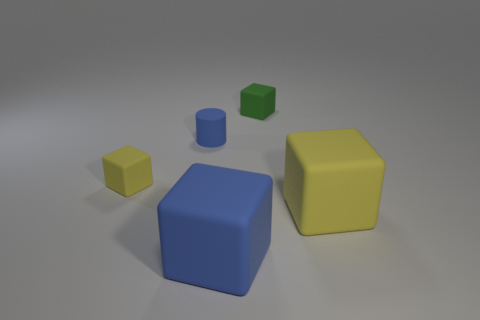How does the lighting in the image affect the appearance of the objects? The soft, diffuse lighting creates gentle shadows and subtly highlights the shapes of the objects, giving a sense of three-dimensionality without causing any harsh glares.  Could you infer the approximate time of day if this were an outdoor setting based on the lighting? If this were an outdoor setting, the soft and diffuse nature of the lighting might suggest an overcast sky, or possibly early morning or late afternoon when sunlight is not as direct. 